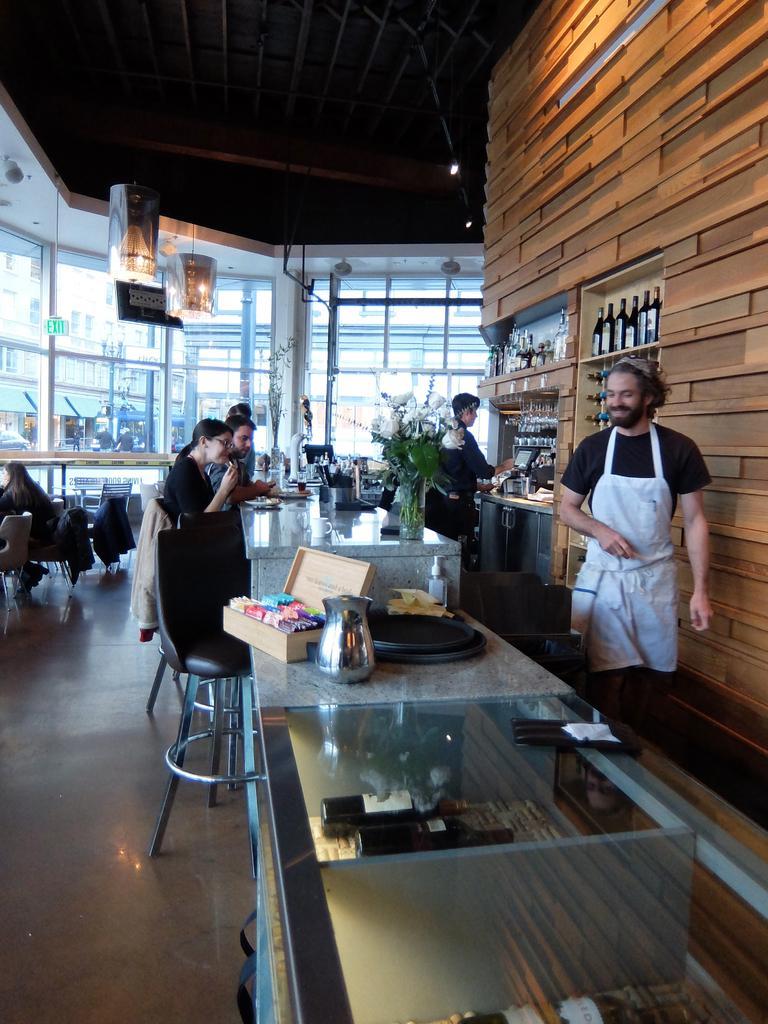Describe this image in one or two sentences. In this image I see people in which most of them are standing and few of them are sitting, I can also see this man is smiling and I see tables in front of them on which there are many things. In the background I see chairs, window glasses, lights on the ceiling and many bottles over here. 